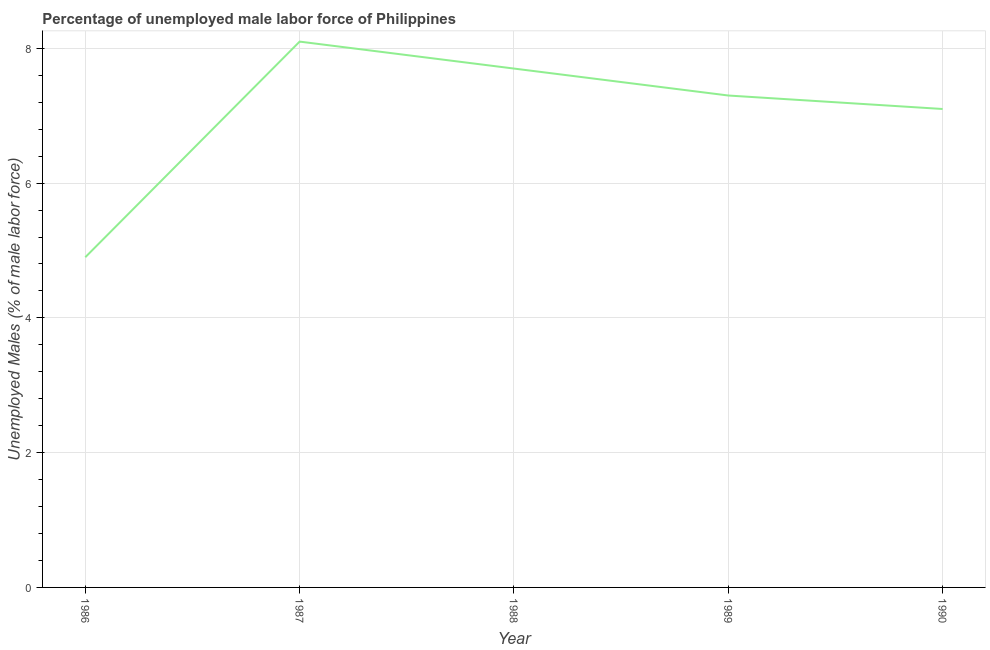What is the total unemployed male labour force in 1988?
Make the answer very short. 7.7. Across all years, what is the maximum total unemployed male labour force?
Make the answer very short. 8.1. Across all years, what is the minimum total unemployed male labour force?
Your answer should be very brief. 4.9. In which year was the total unemployed male labour force minimum?
Provide a short and direct response. 1986. What is the sum of the total unemployed male labour force?
Keep it short and to the point. 35.1. What is the difference between the total unemployed male labour force in 1988 and 1990?
Ensure brevity in your answer.  0.6. What is the average total unemployed male labour force per year?
Offer a terse response. 7.02. What is the median total unemployed male labour force?
Your answer should be compact. 7.3. What is the ratio of the total unemployed male labour force in 1987 to that in 1988?
Your answer should be compact. 1.05. What is the difference between the highest and the second highest total unemployed male labour force?
Ensure brevity in your answer.  0.4. Is the sum of the total unemployed male labour force in 1987 and 1990 greater than the maximum total unemployed male labour force across all years?
Provide a short and direct response. Yes. What is the difference between the highest and the lowest total unemployed male labour force?
Your response must be concise. 3.2. In how many years, is the total unemployed male labour force greater than the average total unemployed male labour force taken over all years?
Keep it short and to the point. 4. How many lines are there?
Offer a terse response. 1. How many years are there in the graph?
Ensure brevity in your answer.  5. What is the difference between two consecutive major ticks on the Y-axis?
Keep it short and to the point. 2. Are the values on the major ticks of Y-axis written in scientific E-notation?
Your answer should be very brief. No. Does the graph contain any zero values?
Your answer should be compact. No. What is the title of the graph?
Ensure brevity in your answer.  Percentage of unemployed male labor force of Philippines. What is the label or title of the Y-axis?
Make the answer very short. Unemployed Males (% of male labor force). What is the Unemployed Males (% of male labor force) of 1986?
Provide a succinct answer. 4.9. What is the Unemployed Males (% of male labor force) in 1987?
Keep it short and to the point. 8.1. What is the Unemployed Males (% of male labor force) in 1988?
Your response must be concise. 7.7. What is the Unemployed Males (% of male labor force) in 1989?
Provide a succinct answer. 7.3. What is the Unemployed Males (% of male labor force) in 1990?
Your response must be concise. 7.1. What is the difference between the Unemployed Males (% of male labor force) in 1986 and 1989?
Offer a very short reply. -2.4. What is the difference between the Unemployed Males (% of male labor force) in 1987 and 1988?
Provide a succinct answer. 0.4. What is the difference between the Unemployed Males (% of male labor force) in 1987 and 1989?
Make the answer very short. 0.8. What is the difference between the Unemployed Males (% of male labor force) in 1987 and 1990?
Make the answer very short. 1. What is the difference between the Unemployed Males (% of male labor force) in 1989 and 1990?
Provide a short and direct response. 0.2. What is the ratio of the Unemployed Males (% of male labor force) in 1986 to that in 1987?
Provide a succinct answer. 0.6. What is the ratio of the Unemployed Males (% of male labor force) in 1986 to that in 1988?
Your answer should be very brief. 0.64. What is the ratio of the Unemployed Males (% of male labor force) in 1986 to that in 1989?
Offer a terse response. 0.67. What is the ratio of the Unemployed Males (% of male labor force) in 1986 to that in 1990?
Offer a very short reply. 0.69. What is the ratio of the Unemployed Males (% of male labor force) in 1987 to that in 1988?
Your answer should be very brief. 1.05. What is the ratio of the Unemployed Males (% of male labor force) in 1987 to that in 1989?
Your answer should be compact. 1.11. What is the ratio of the Unemployed Males (% of male labor force) in 1987 to that in 1990?
Your answer should be very brief. 1.14. What is the ratio of the Unemployed Males (% of male labor force) in 1988 to that in 1989?
Your answer should be very brief. 1.05. What is the ratio of the Unemployed Males (% of male labor force) in 1988 to that in 1990?
Make the answer very short. 1.08. What is the ratio of the Unemployed Males (% of male labor force) in 1989 to that in 1990?
Keep it short and to the point. 1.03. 